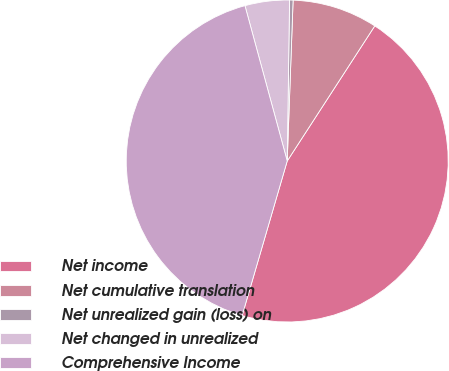<chart> <loc_0><loc_0><loc_500><loc_500><pie_chart><fcel>Net income<fcel>Net cumulative translation<fcel>Net unrealized gain (loss) on<fcel>Net changed in unrealized<fcel>Comprehensive Income<nl><fcel>45.36%<fcel>8.57%<fcel>0.35%<fcel>4.46%<fcel>41.25%<nl></chart> 